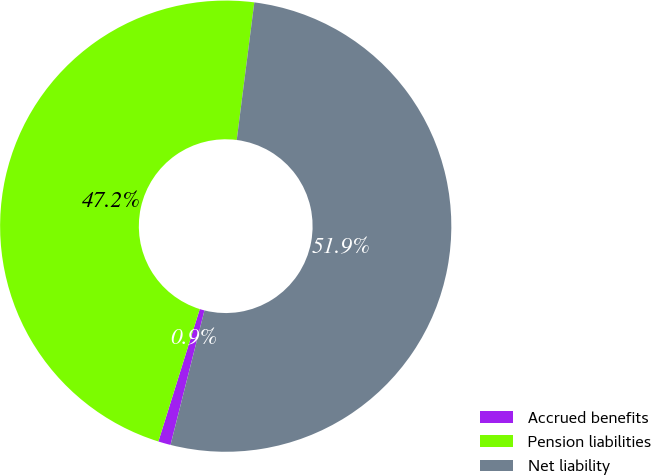Convert chart to OTSL. <chart><loc_0><loc_0><loc_500><loc_500><pie_chart><fcel>Accrued benefits<fcel>Pension liabilities<fcel>Net liability<nl><fcel>0.89%<fcel>47.2%<fcel>51.91%<nl></chart> 